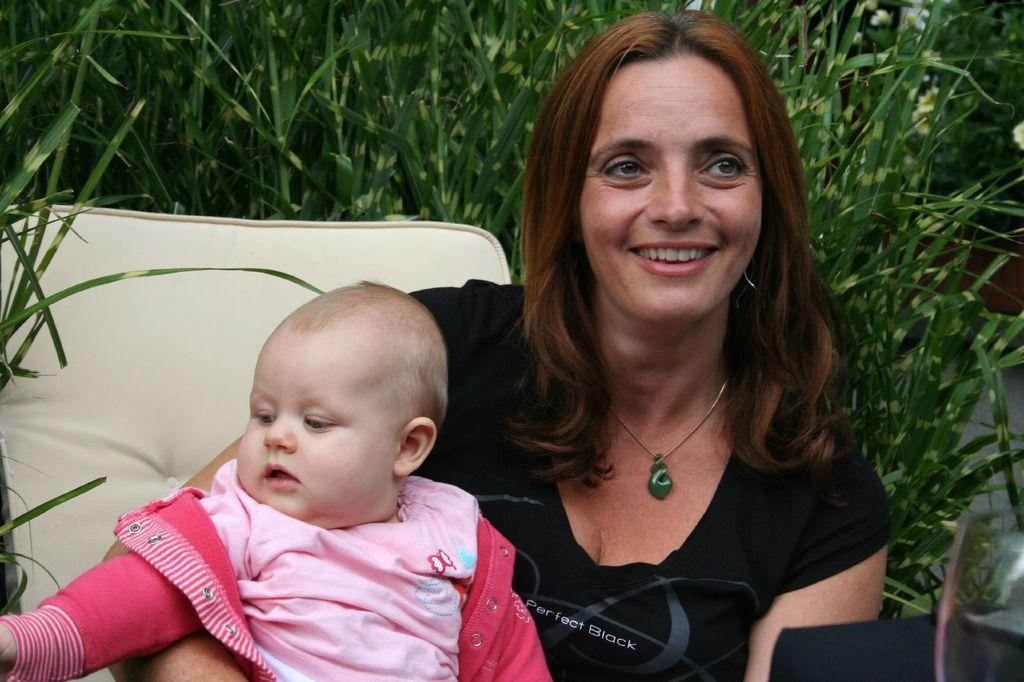Who is the main subject in the image? There is a woman in the image. What is the woman wearing? The woman is wearing a black t-shirt. What is the woman doing in the image? The woman is holding a baby. What is the woman's position in the image? The woman is sitting on a chair. What type of flooring can be seen in the background? There is grass on the floor in the background. How many tomatoes are on the woman's head in the image? There are no tomatoes present on the woman's head in the image. What direction is the sun shining from in the image? The image does not provide information about the sun or its direction. --- Facts: 1. There is a car in the image. 2. The car is red. 3. The car has four wheels. 4. There are people in the car. 5. The car is parked on the street. Absurd Topics: fish, ocean, waves Conversation: What is the main subject in the image? There is a car in the image. What color is the car? The car is red. How many wheels does the car have? The car has four wheels. Who is inside the car? There are people in the car. Where is the car located in the image? The car is parked on the street. Reasoning: Let's think step by step in order to produce the conversation. We start by identifying the main subject in the image, which is the car. Then, we describe the car's color and the number of wheels it has. Next, we mention who is inside the car, which are people. Finally, we describe the car's location in the image, which is parked on the street. Each question is designed to elicit a specific detail about the image that is known from the provided facts. Absurd Question/Answer: How many fish can be seen swimming in the ocean in the image? There are no fish or ocean present in the image. What type of waves can be seen crashing on the shore in the image? There are no waves or shore present in the image. 